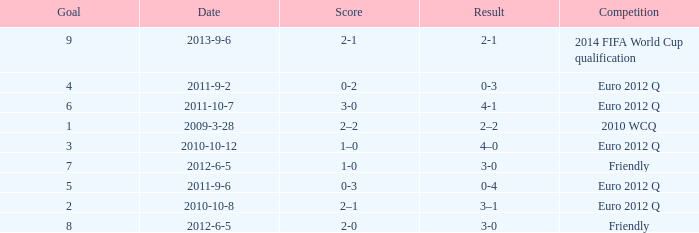In the euro 2012 quarterfinals with a 3-0 score, what is the total number of goals? 1.0. 